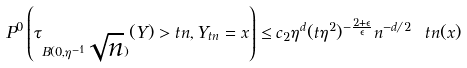<formula> <loc_0><loc_0><loc_500><loc_500>P ^ { 0 } \left ( \tau _ { B ( 0 , \eta ^ { - 1 } \sqrt { n } ) } ( Y ) > t n , Y _ { t n } = x \right ) \leq c _ { 2 } \eta ^ { d } ( t \eta ^ { 2 } ) ^ { - \frac { 2 + \epsilon } \epsilon } n ^ { - d / 2 } \ t n ( x )</formula> 